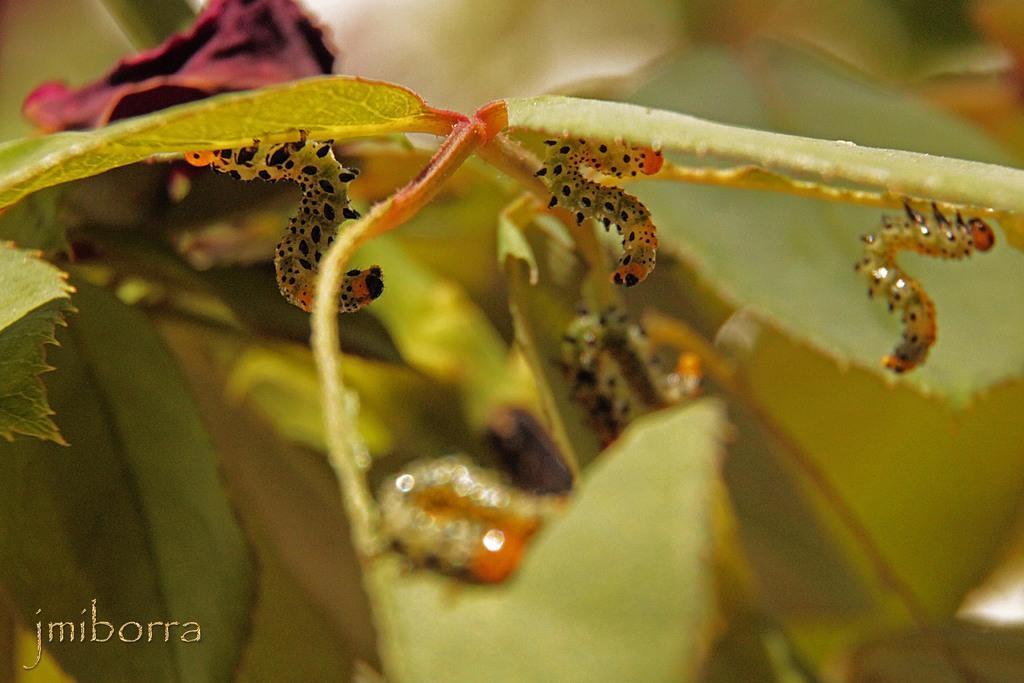Can you describe this image briefly? In this image there are few caterpillars on the plant having leaves. 